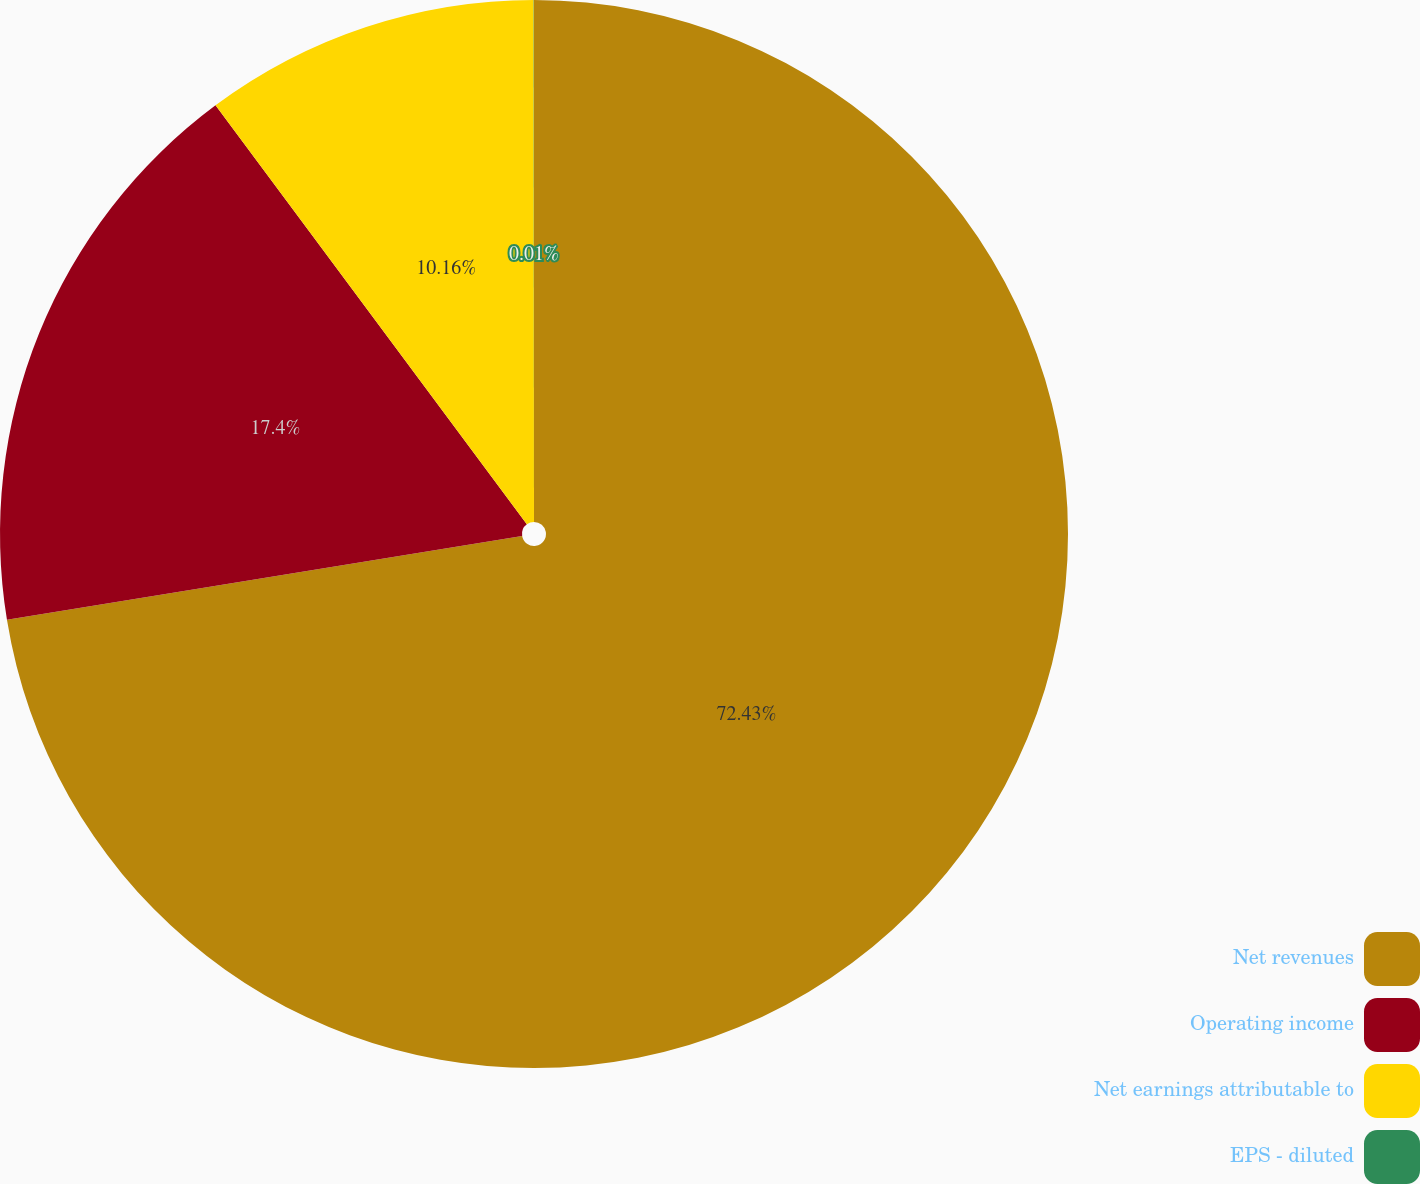<chart> <loc_0><loc_0><loc_500><loc_500><pie_chart><fcel>Net revenues<fcel>Operating income<fcel>Net earnings attributable to<fcel>EPS - diluted<nl><fcel>72.43%<fcel>17.4%<fcel>10.16%<fcel>0.01%<nl></chart> 